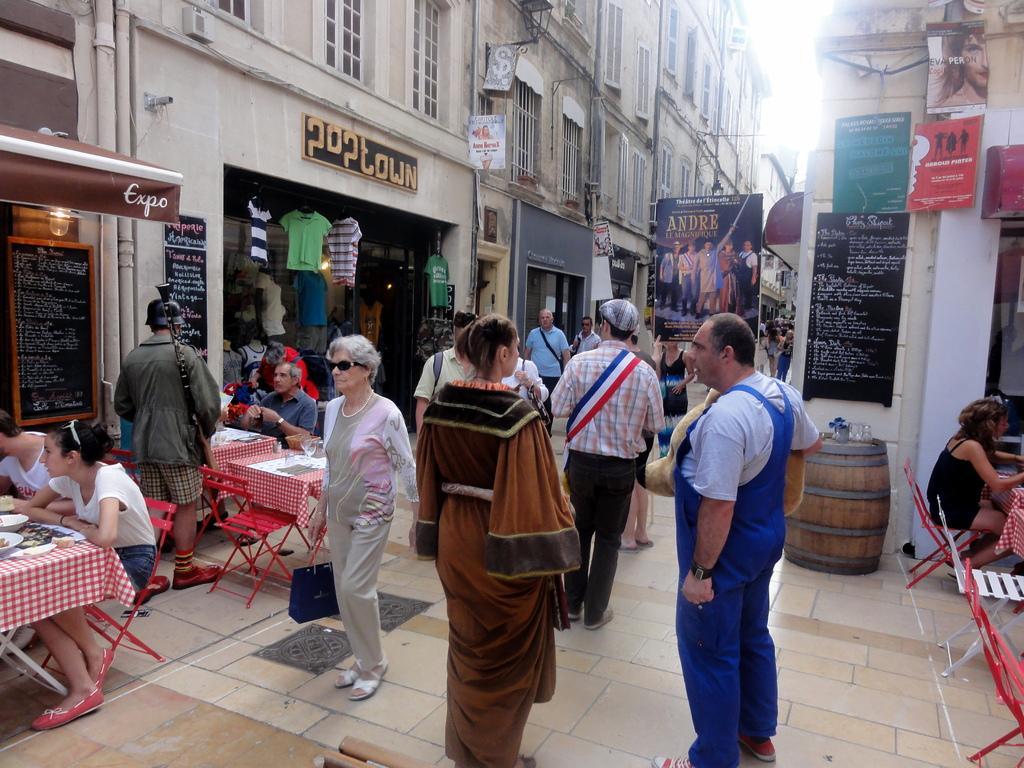Could you give a brief overview of what you see in this image? There are group of people in a street and there are tables and chairs on the either side of the street. 